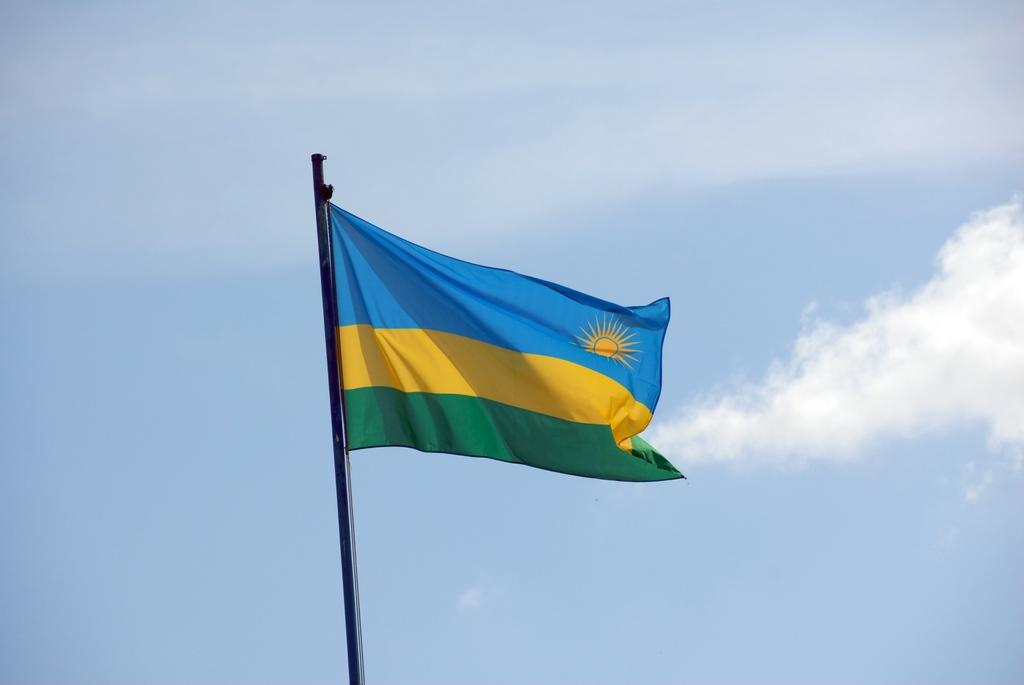What is the color of the pole in the image? The pole in the image is black. What is attached to the pole? A flag is attached to the pole. What colors can be seen on the flag? The flag has blue, yellow, and green colors. What can be seen in the background of the image? The sky is visible in the background of the image. What type of furniture can be seen in the image? There is no furniture present in the image. What kind of seed is growing on the pole in the image? There are no seeds growing on the pole in the image; it is a flag attached to the pole. 